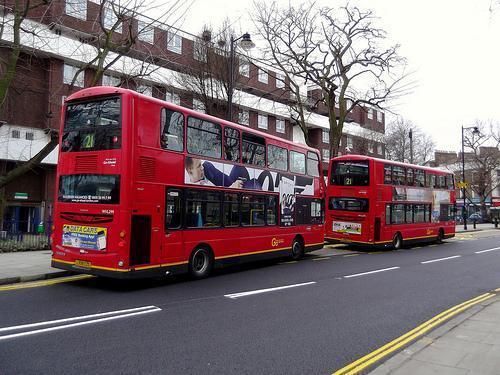How many buses are pictured here?
Give a very brief answer. 2. How many people are in this picture?
Give a very brief answer. 0. How many windows are one the back of each bus?
Give a very brief answer. 2. 